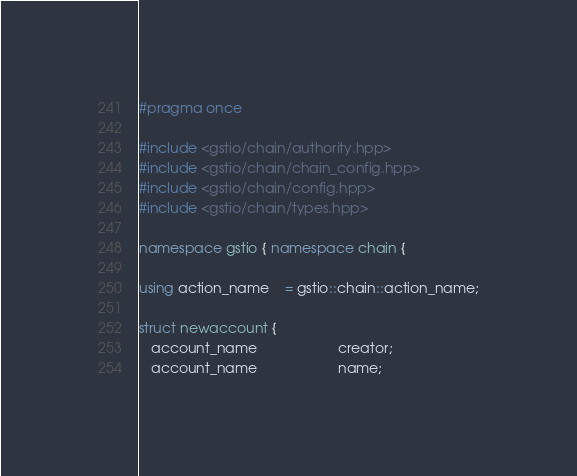Convert code to text. <code><loc_0><loc_0><loc_500><loc_500><_C++_>#pragma once

#include <gstio/chain/authority.hpp>
#include <gstio/chain/chain_config.hpp>
#include <gstio/chain/config.hpp>
#include <gstio/chain/types.hpp>

namespace gstio { namespace chain {

using action_name    = gstio::chain::action_name;

struct newaccount {
   account_name                     creator;
   account_name                     name;</code> 